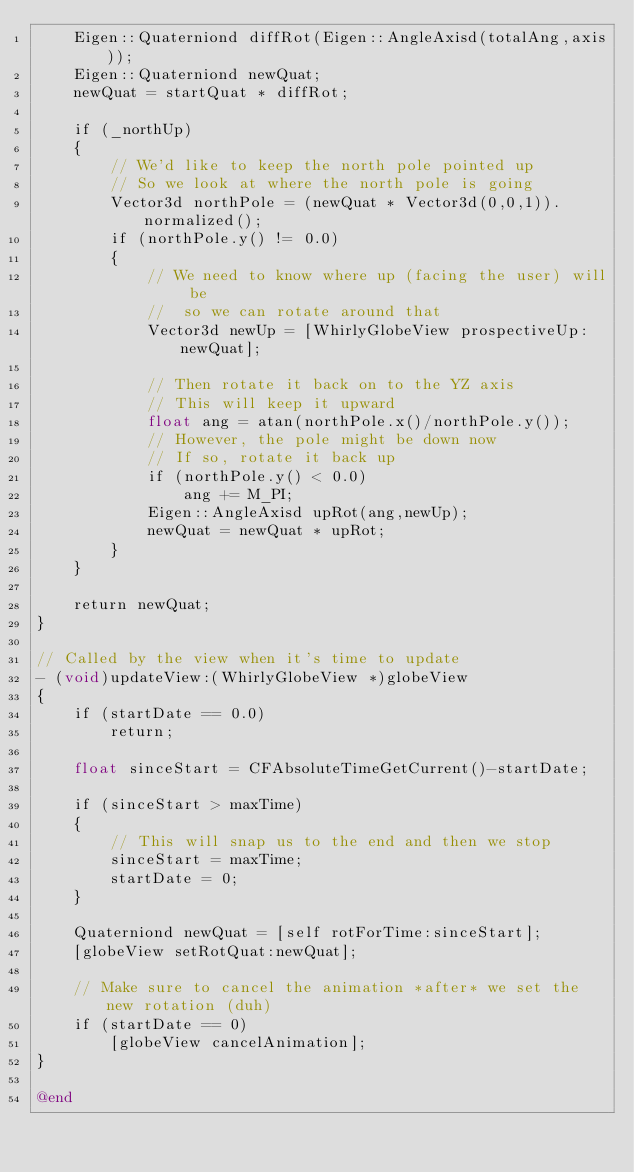<code> <loc_0><loc_0><loc_500><loc_500><_ObjectiveC_>    Eigen::Quaterniond diffRot(Eigen::AngleAxisd(totalAng,axis));
    Eigen::Quaterniond newQuat;
    newQuat = startQuat * diffRot;

    if (_northUp)
    {
        // We'd like to keep the north pole pointed up
        // So we look at where the north pole is going
        Vector3d northPole = (newQuat * Vector3d(0,0,1)).normalized();
        if (northPole.y() != 0.0)
        {
            // We need to know where up (facing the user) will be
            //  so we can rotate around that
            Vector3d newUp = [WhirlyGlobeView prospectiveUp:newQuat];
            
            // Then rotate it back on to the YZ axis
            // This will keep it upward
            float ang = atan(northPole.x()/northPole.y());
            // However, the pole might be down now
            // If so, rotate it back up
            if (northPole.y() < 0.0)
                ang += M_PI;
            Eigen::AngleAxisd upRot(ang,newUp);
            newQuat = newQuat * upRot;
        }
    }

    return newQuat;
}

// Called by the view when it's time to update
- (void)updateView:(WhirlyGlobeView *)globeView
{
    if (startDate == 0.0)
        return;
    
	float sinceStart = CFAbsoluteTimeGetCurrent()-startDate;
    
    if (sinceStart > maxTime)
    {
        // This will snap us to the end and then we stop
        sinceStart = maxTime;
        startDate = 0;
    }
    
    Quaterniond newQuat = [self rotForTime:sinceStart];
    [globeView setRotQuat:newQuat];
    
    // Make sure to cancel the animation *after* we set the new rotation (duh)
    if (startDate == 0)
        [globeView cancelAnimation];
}

@end
</code> 